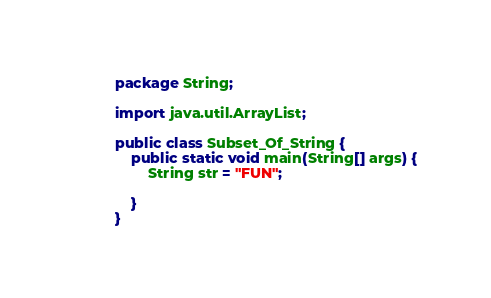Convert code to text. <code><loc_0><loc_0><loc_500><loc_500><_Java_>package String;

import java.util.ArrayList;

public class Subset_Of_String {
    public static void main(String[] args) {
        String str = "FUN";

    }
}
</code> 